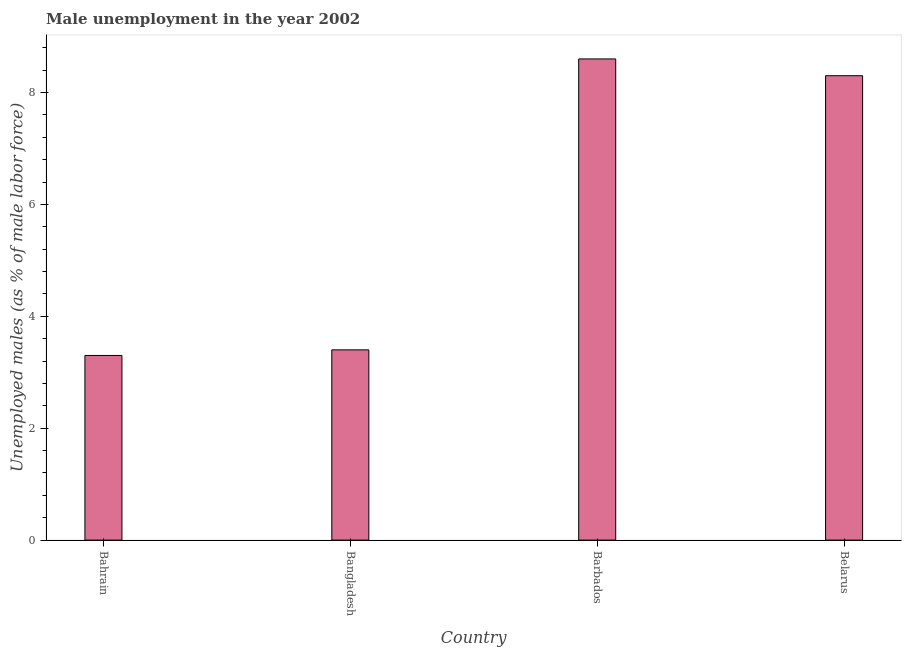Does the graph contain any zero values?
Keep it short and to the point. No. Does the graph contain grids?
Provide a short and direct response. No. What is the title of the graph?
Offer a very short reply. Male unemployment in the year 2002. What is the label or title of the Y-axis?
Your answer should be compact. Unemployed males (as % of male labor force). What is the unemployed males population in Barbados?
Offer a very short reply. 8.6. Across all countries, what is the maximum unemployed males population?
Provide a short and direct response. 8.6. Across all countries, what is the minimum unemployed males population?
Keep it short and to the point. 3.3. In which country was the unemployed males population maximum?
Ensure brevity in your answer.  Barbados. In which country was the unemployed males population minimum?
Offer a very short reply. Bahrain. What is the sum of the unemployed males population?
Offer a very short reply. 23.6. What is the average unemployed males population per country?
Give a very brief answer. 5.9. What is the median unemployed males population?
Give a very brief answer. 5.85. In how many countries, is the unemployed males population greater than 0.4 %?
Provide a short and direct response. 4. What is the ratio of the unemployed males population in Bangladesh to that in Barbados?
Provide a short and direct response. 0.4. Is the difference between the unemployed males population in Bahrain and Barbados greater than the difference between any two countries?
Keep it short and to the point. Yes. What is the difference between the highest and the second highest unemployed males population?
Provide a short and direct response. 0.3. Is the sum of the unemployed males population in Bangladesh and Barbados greater than the maximum unemployed males population across all countries?
Provide a short and direct response. Yes. What is the difference between the highest and the lowest unemployed males population?
Ensure brevity in your answer.  5.3. In how many countries, is the unemployed males population greater than the average unemployed males population taken over all countries?
Your response must be concise. 2. How many bars are there?
Keep it short and to the point. 4. Are all the bars in the graph horizontal?
Make the answer very short. No. How many countries are there in the graph?
Your answer should be compact. 4. What is the difference between two consecutive major ticks on the Y-axis?
Offer a very short reply. 2. Are the values on the major ticks of Y-axis written in scientific E-notation?
Your answer should be very brief. No. What is the Unemployed males (as % of male labor force) of Bahrain?
Keep it short and to the point. 3.3. What is the Unemployed males (as % of male labor force) in Bangladesh?
Your response must be concise. 3.4. What is the Unemployed males (as % of male labor force) of Barbados?
Keep it short and to the point. 8.6. What is the Unemployed males (as % of male labor force) in Belarus?
Offer a terse response. 8.3. What is the difference between the Unemployed males (as % of male labor force) in Bahrain and Bangladesh?
Your response must be concise. -0.1. What is the difference between the Unemployed males (as % of male labor force) in Bahrain and Barbados?
Ensure brevity in your answer.  -5.3. What is the difference between the Unemployed males (as % of male labor force) in Bahrain and Belarus?
Your response must be concise. -5. What is the difference between the Unemployed males (as % of male labor force) in Barbados and Belarus?
Your answer should be very brief. 0.3. What is the ratio of the Unemployed males (as % of male labor force) in Bahrain to that in Barbados?
Your answer should be very brief. 0.38. What is the ratio of the Unemployed males (as % of male labor force) in Bahrain to that in Belarus?
Your response must be concise. 0.4. What is the ratio of the Unemployed males (as % of male labor force) in Bangladesh to that in Barbados?
Your answer should be compact. 0.4. What is the ratio of the Unemployed males (as % of male labor force) in Bangladesh to that in Belarus?
Ensure brevity in your answer.  0.41. What is the ratio of the Unemployed males (as % of male labor force) in Barbados to that in Belarus?
Your response must be concise. 1.04. 